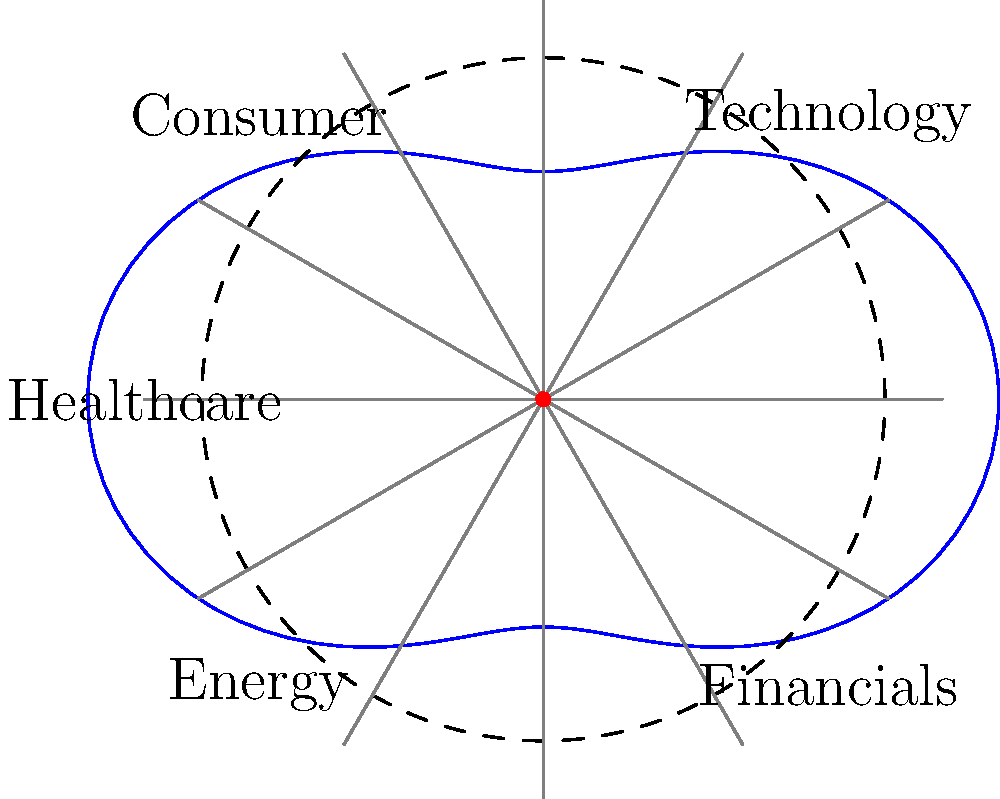In the polar coordinate representation of sector rotation in the stock market, the distance from the origin represents sector performance, while the angle represents time progression through a market cycle. The blue curve shows the relative performance of sectors over time, with the dashed circle indicating average performance. If the equation of this curve is given by $r = 3 + \cos(2\theta)$, at what angle $\theta$ (in radians) does the Technology sector reach its peak performance? To find the angle at which the Technology sector reaches its peak performance, we need to follow these steps:

1) The equation given is $r = 3 + \cos(2\theta)$, where $r$ represents the sector's performance and $\theta$ represents the angle (time in the market cycle).

2) The Technology sector is located in the first quadrant, around 45 degrees or $\frac{\pi}{4}$ radians.

3) To find the maximum value of $r$, we need to find where $\frac{dr}{d\theta} = 0$:

   $\frac{dr}{d\theta} = -2\sin(2\theta)$

4) Setting this equal to zero:

   $-2\sin(2\theta) = 0$
   $\sin(2\theta) = 0$

5) The solutions to this equation are:

   $2\theta = 0, \pi, 2\pi, ...$
   $\theta = 0, \frac{\pi}{2}, \pi, ...$

6) Given that the Technology sector is in the first quadrant, the relevant solution is $\theta = \frac{\pi}{4}$.

7) We can confirm this is a maximum (not a minimum) by checking the second derivative is negative at this point.
Answer: $\frac{\pi}{4}$ radians 